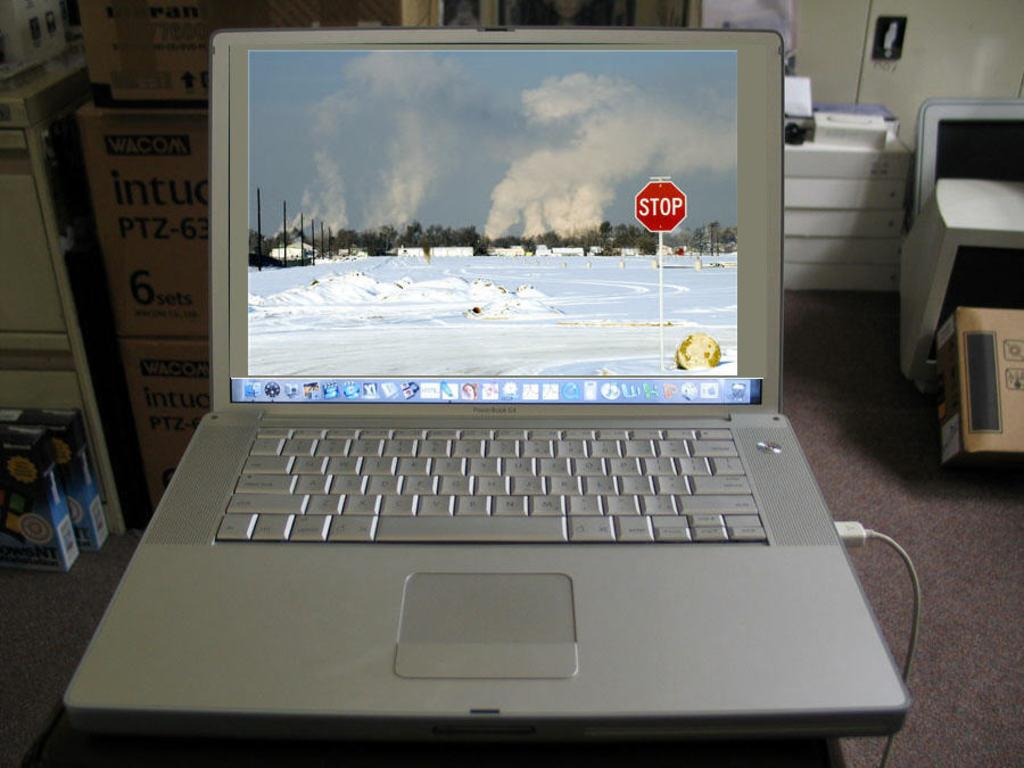<image>
Create a compact narrative representing the image presented. A laptop is powered on and displays a snow covered area with a stop sign. 